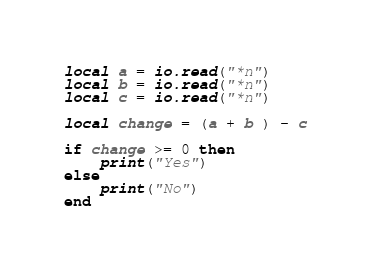<code> <loc_0><loc_0><loc_500><loc_500><_Lua_>local a = io.read("*n")
local b = io.read("*n")
local c = io.read("*n")

local change = (a + b ) - c

if change >= 0 then
    print("Yes")
else
    print("No")
end</code> 